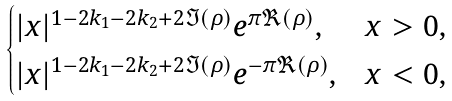<formula> <loc_0><loc_0><loc_500><loc_500>\begin{cases} | x | ^ { 1 - 2 k _ { 1 } - 2 k _ { 2 } + 2 \Im ( \rho ) } e ^ { \pi \Re ( \rho ) } , & x > 0 , \\ | x | ^ { 1 - 2 k _ { 1 } - 2 k _ { 2 } + 2 \Im ( \rho ) } e ^ { - \pi \Re ( \rho ) } , & x < 0 , \end{cases}</formula> 